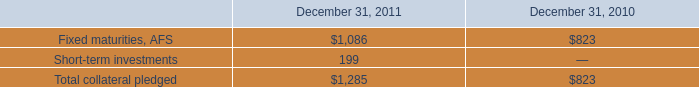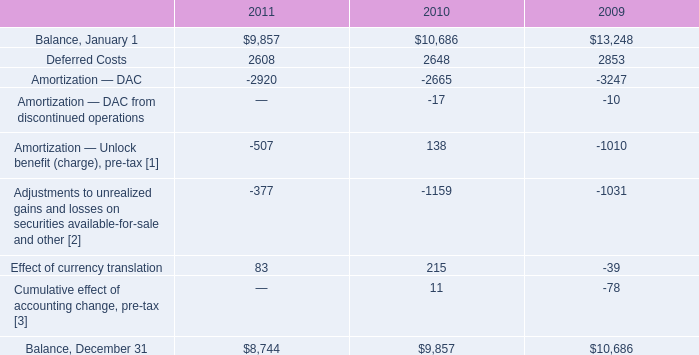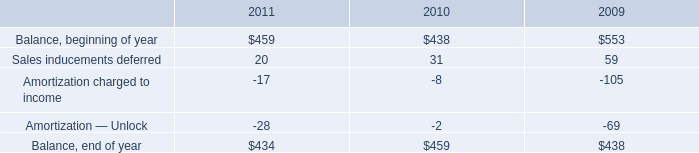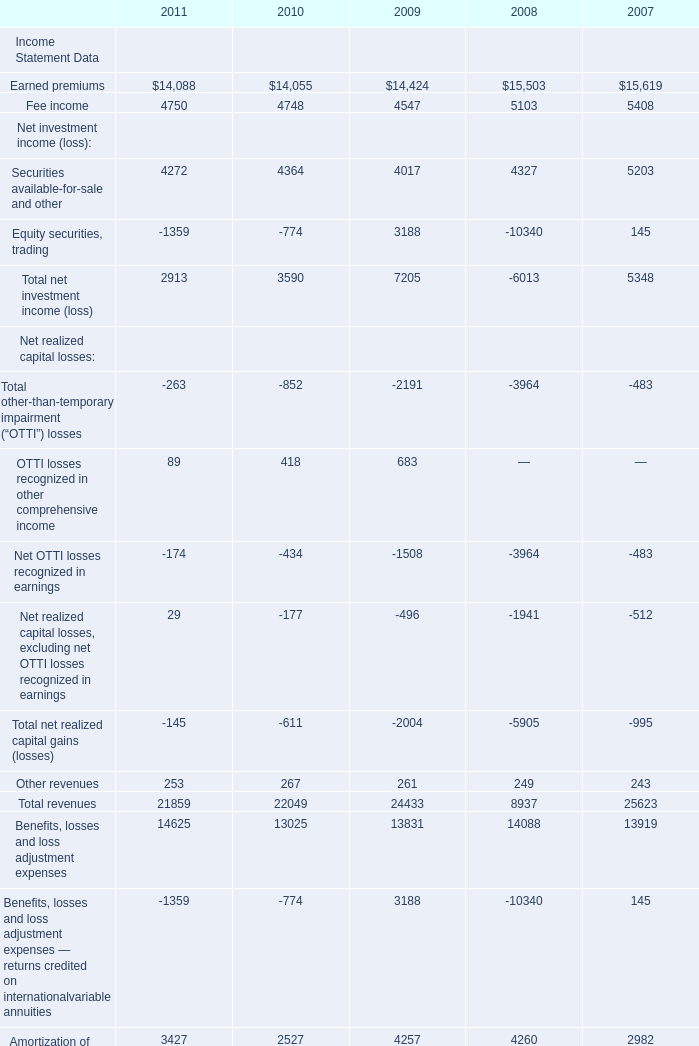What is the total amount of Fee income of 2007, Balance, January 1 of 2011, and Total assets Balance Sheet Data of 2009 ? 
Computations: ((5408.0 + 9857.0) + 307717.0)
Answer: 322982.0. 